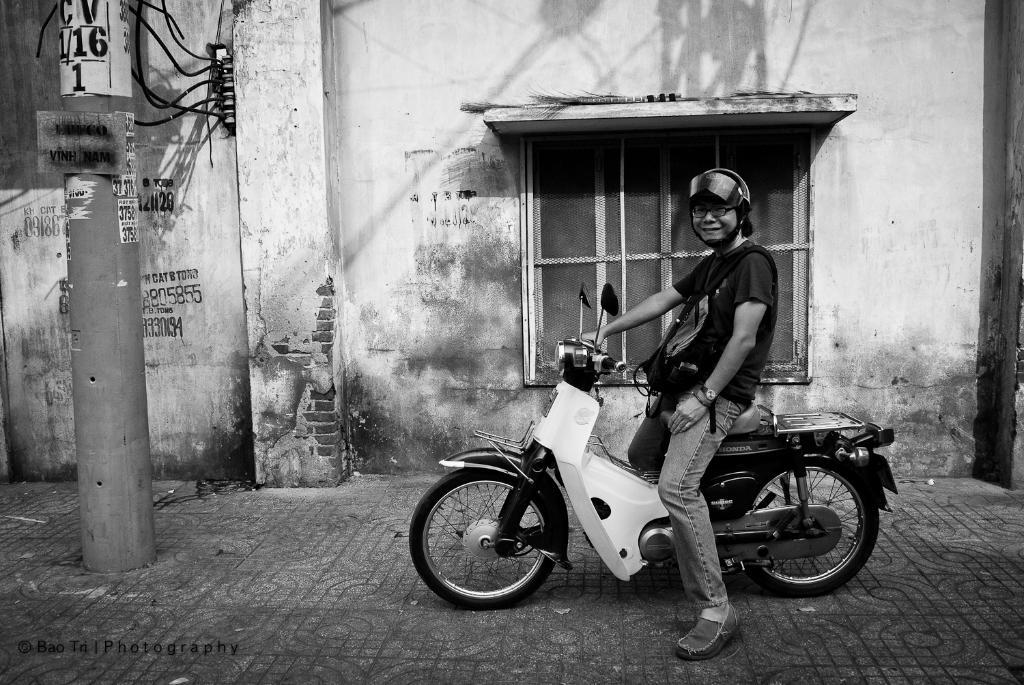What is the color scheme of the image? The image is black and white. What is the man in the image doing? The man is sitting on a motorbike. What is the man wearing on his head? The man is wearing a helmet. What type of structure can be seen in the image? There is a building with windows in the image. What is located in front of the building? There is a current pole in front of the building. What is the reason for the man's trip to the office in the image? There is no indication of a trip or an office in the image. The man is simply sitting on a motorbike in front of a building with a current pole. 